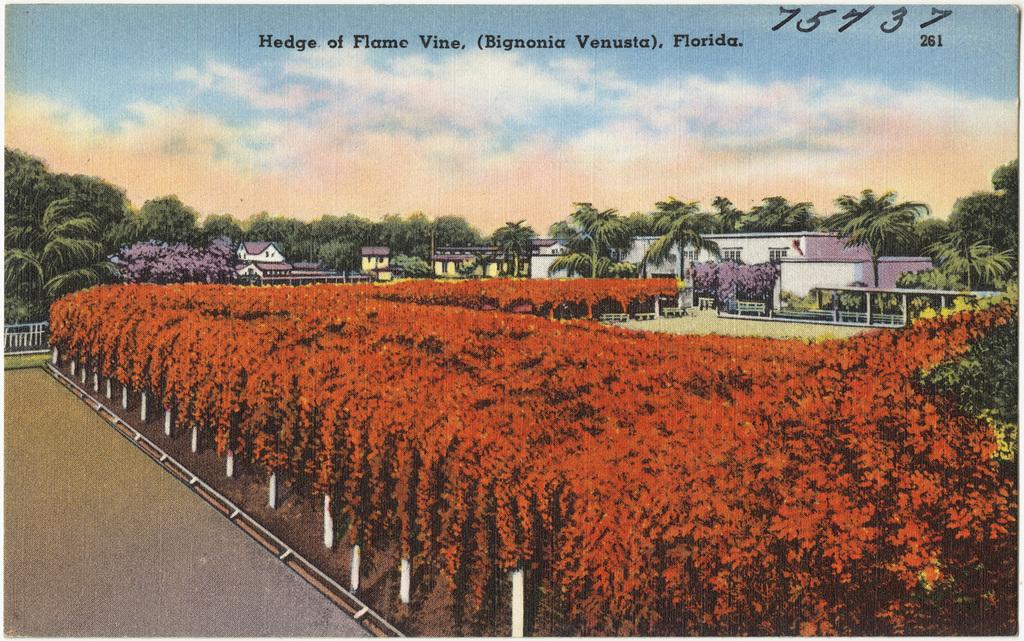What type of natural elements can be seen in the image? There are trees and plants visible in the image. What type of man-made structures are present in the image? There are houses and poles visible in the image. What is visible in the sky in the image? There are clouds visible in the sky in the image. Is there any text present in the image? Yes, there is some text visible in the image. What type of string is being used as a guide for education in the image? There is no string or reference to education present in the image. 